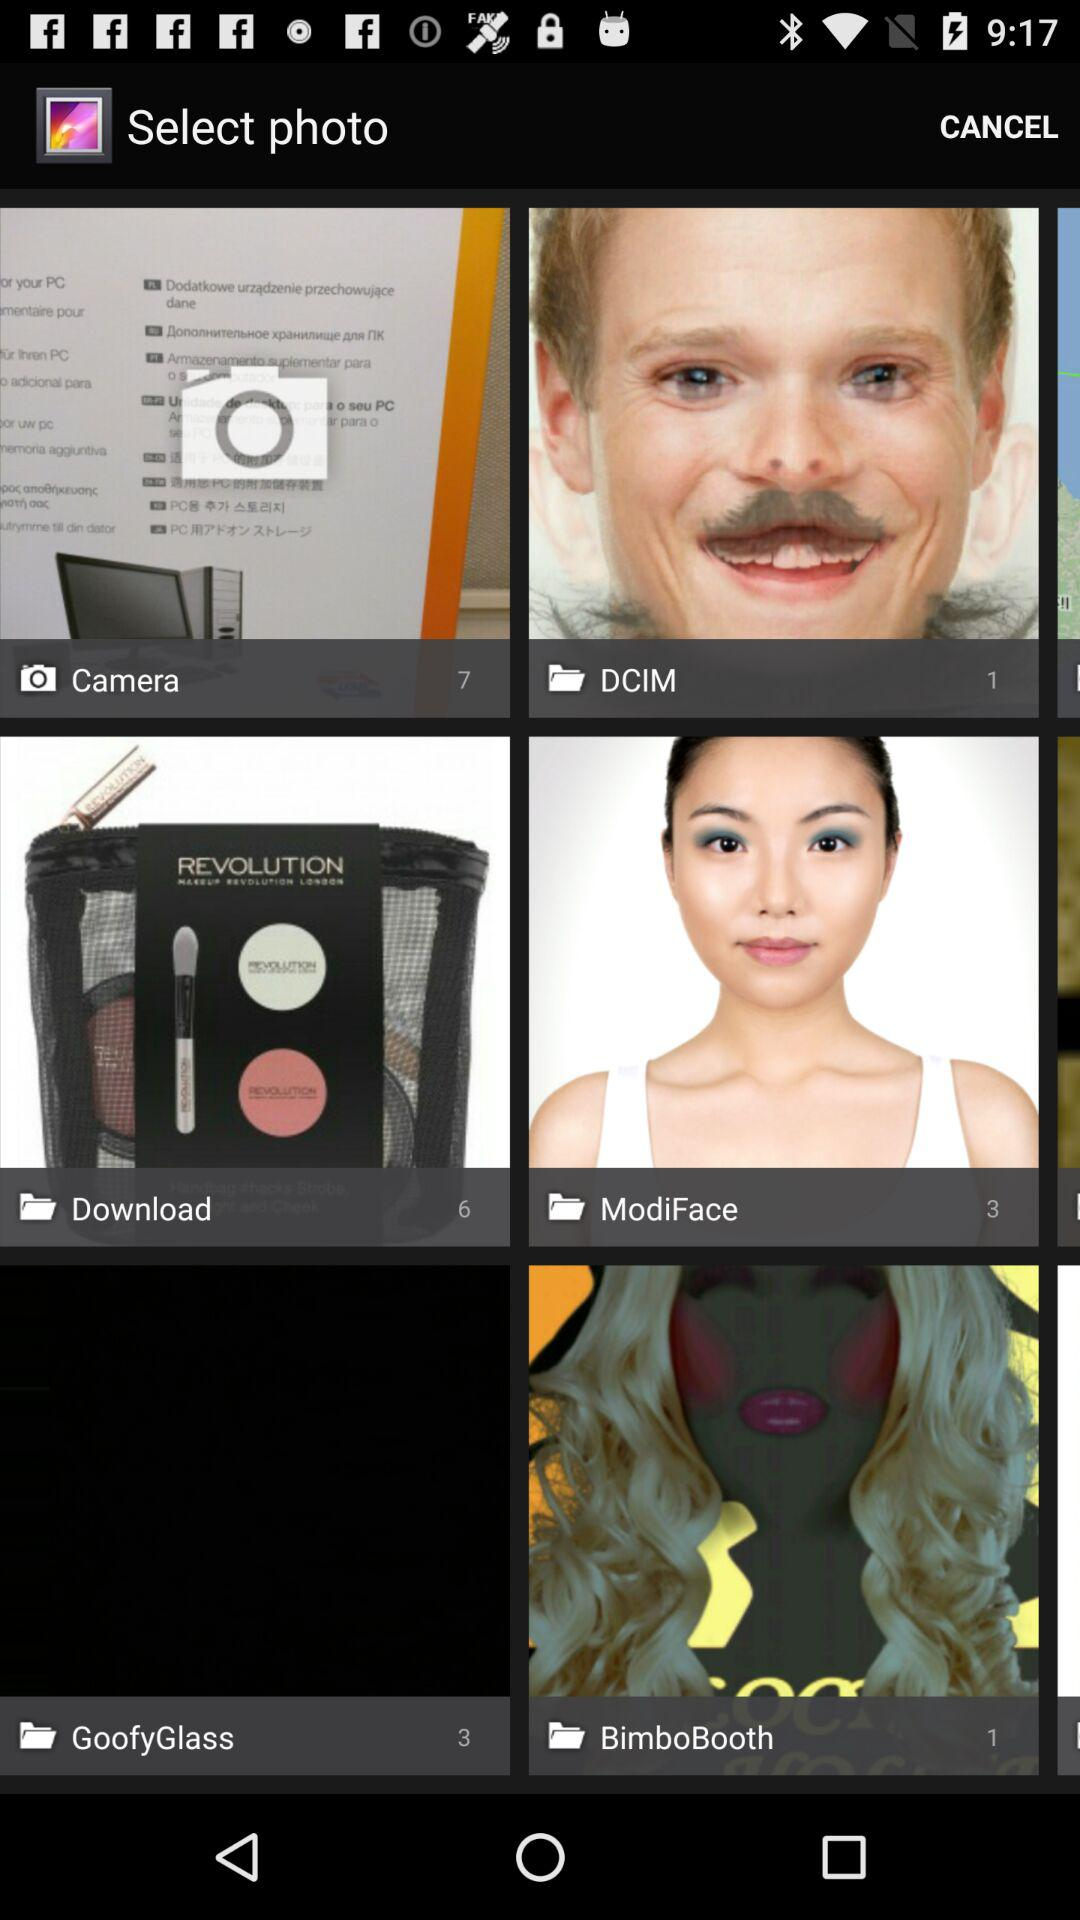What is the number of photos in "GoofyGlass"? The number of photos in "GoofyGlass" is 3. 